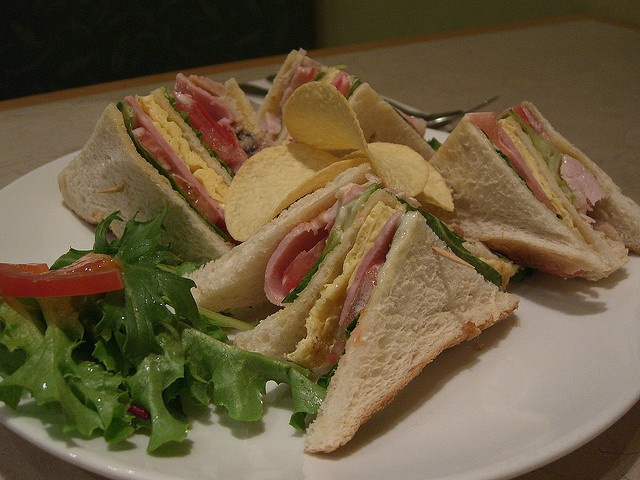Describe the objects in this image and their specific colors. I can see sandwich in black, tan, gray, olive, and maroon tones, dining table in black, gray, and maroon tones, sandwich in black, gray, olive, tan, and maroon tones, sandwich in black, gray, olive, and tan tones, and sandwich in black, olive, gray, and maroon tones in this image. 